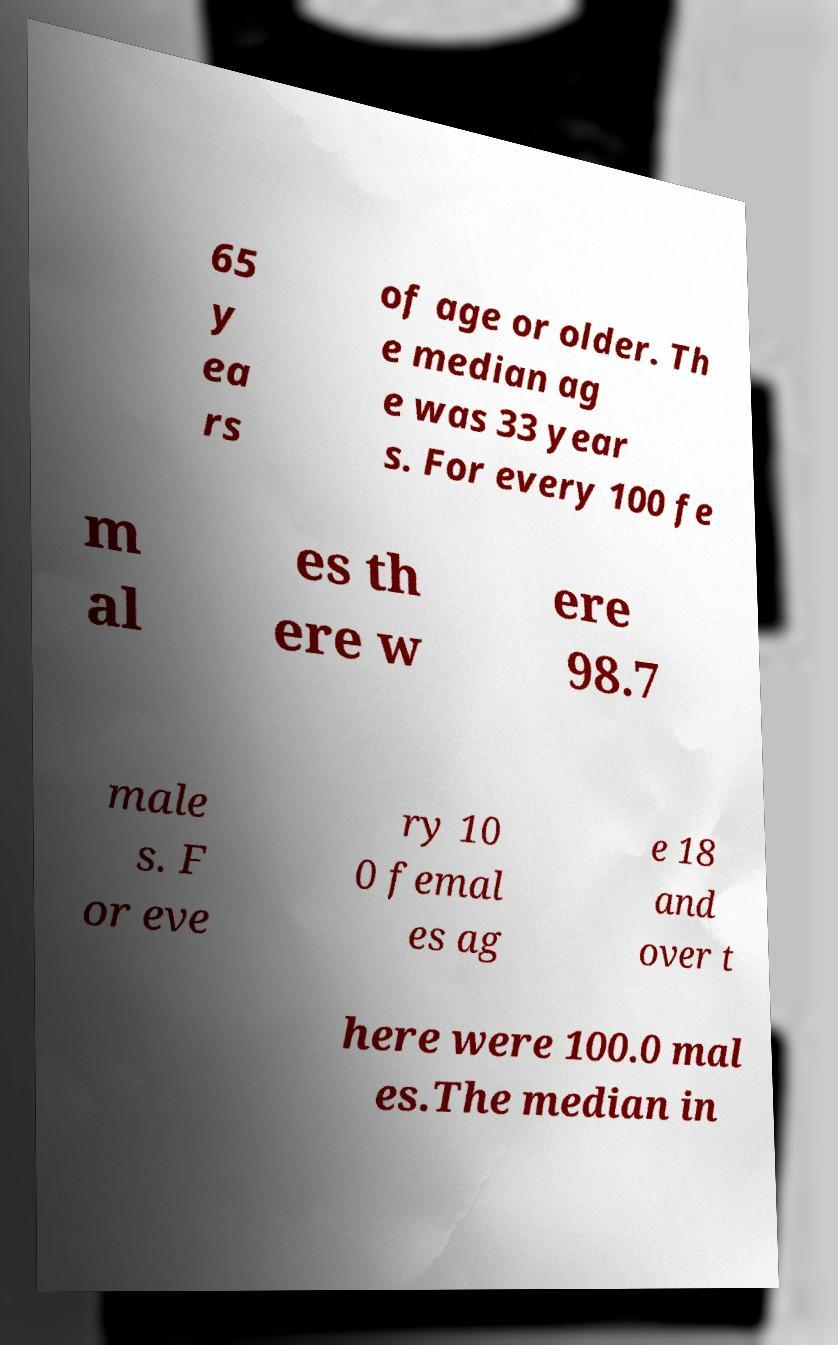Can you accurately transcribe the text from the provided image for me? 65 y ea rs of age or older. Th e median ag e was 33 year s. For every 100 fe m al es th ere w ere 98.7 male s. F or eve ry 10 0 femal es ag e 18 and over t here were 100.0 mal es.The median in 